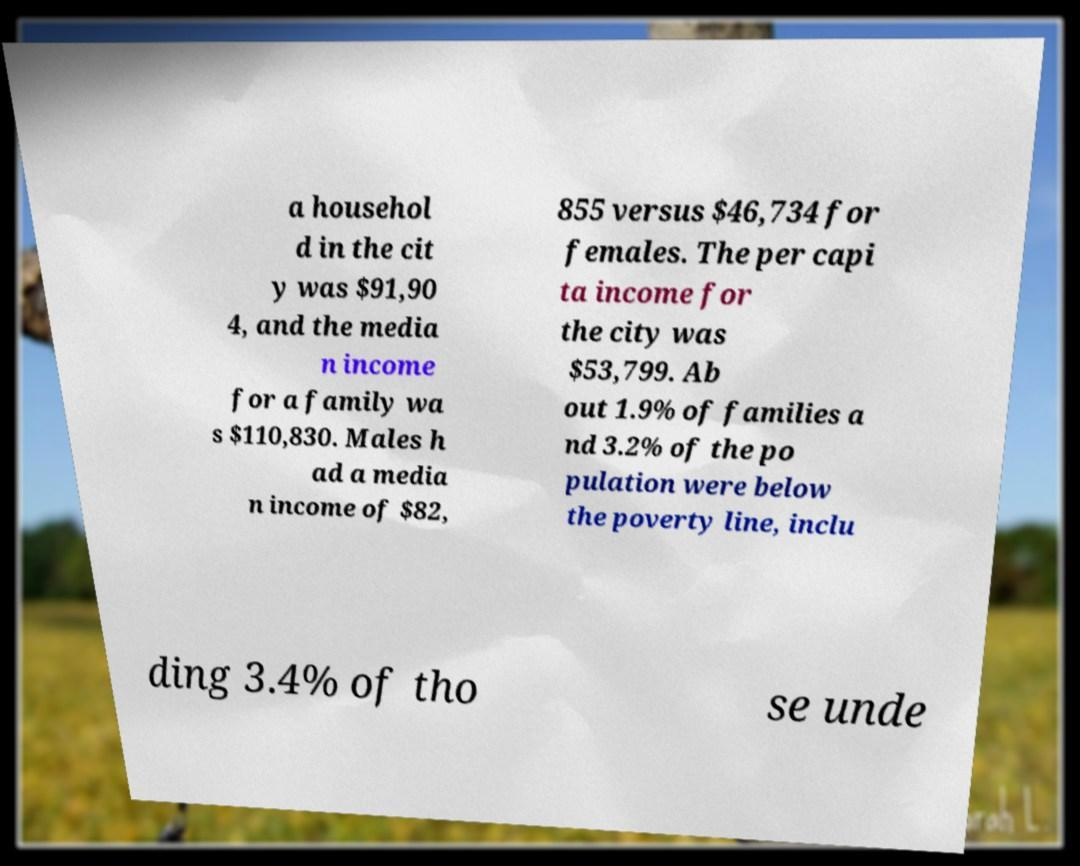Could you assist in decoding the text presented in this image and type it out clearly? a househol d in the cit y was $91,90 4, and the media n income for a family wa s $110,830. Males h ad a media n income of $82, 855 versus $46,734 for females. The per capi ta income for the city was $53,799. Ab out 1.9% of families a nd 3.2% of the po pulation were below the poverty line, inclu ding 3.4% of tho se unde 